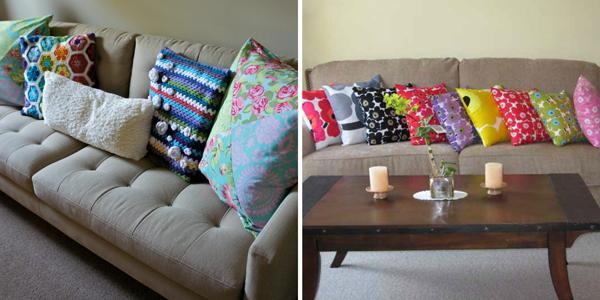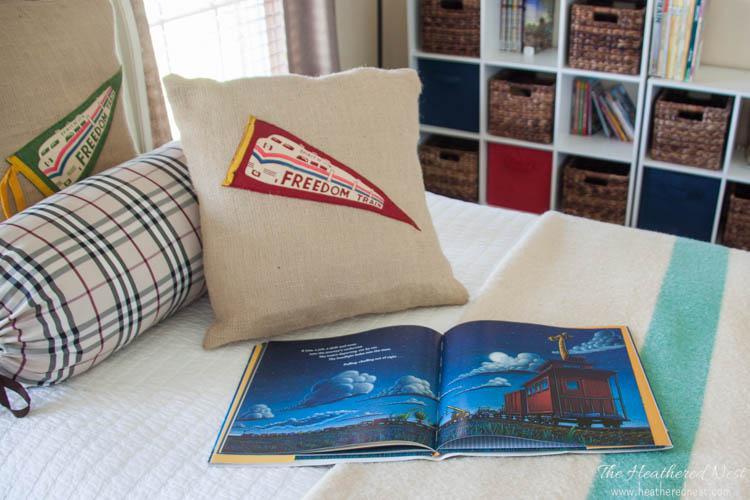The first image is the image on the left, the second image is the image on the right. Given the left and right images, does the statement "The sofa in the image on the left is buried in pillows" hold true? Answer yes or no. No. The first image is the image on the left, the second image is the image on the right. For the images shown, is this caption "At least one image has no more than two pillows." true? Answer yes or no. Yes. 